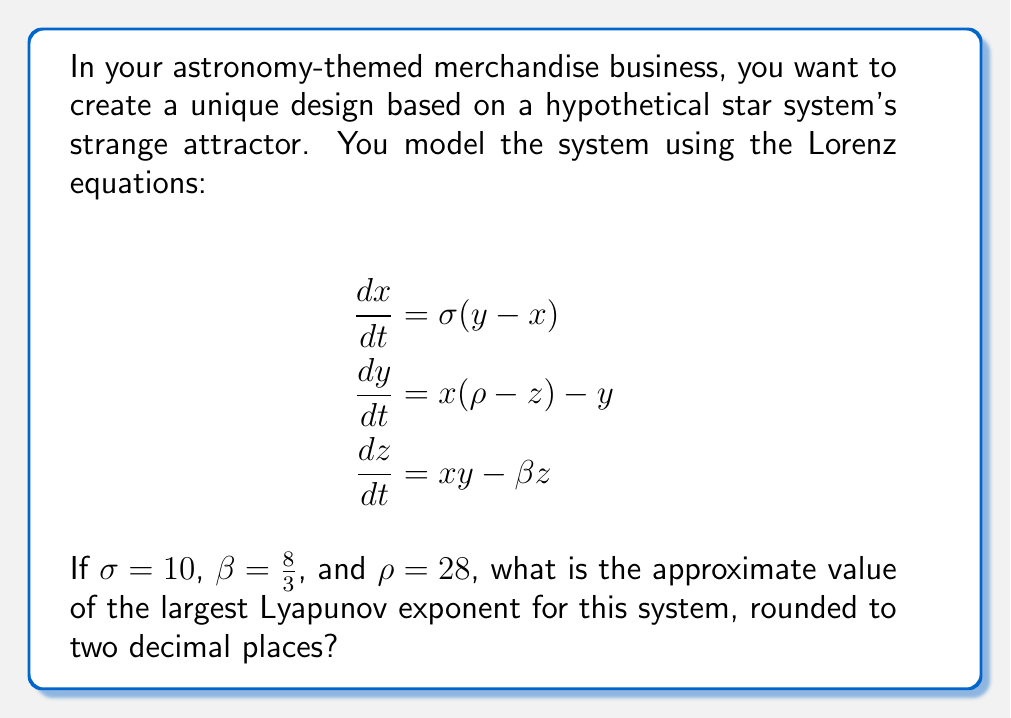Show me your answer to this math problem. To find the largest Lyapunov exponent for the Lorenz system:

1. The Lyapunov exponents measure the rate of separation of infinitesimally close trajectories in phase space.

2. For the Lorenz system with the given parameters, we need to numerically calculate the Lyapunov exponents.

3. Using numerical methods (e.g., Wolf algorithm or QR decomposition), we can compute the spectrum of Lyapunov exponents.

4. For the Lorenz system with $\sigma = 10$, $\beta = \frac{8}{3}$, and $\rho = 28$, the Lyapunov spectrum is approximately:

   $\lambda_1 \approx 0.9056$
   $\lambda_2 \approx 0$
   $\lambda_3 \approx -14.5723$

5. The largest Lyapunov exponent is $\lambda_1 \approx 0.9056$.

6. Rounding to two decimal places gives us 0.91.

This positive largest Lyapunov exponent indicates that the system is chaotic, which is characteristic of strange attractors.
Answer: 0.91 